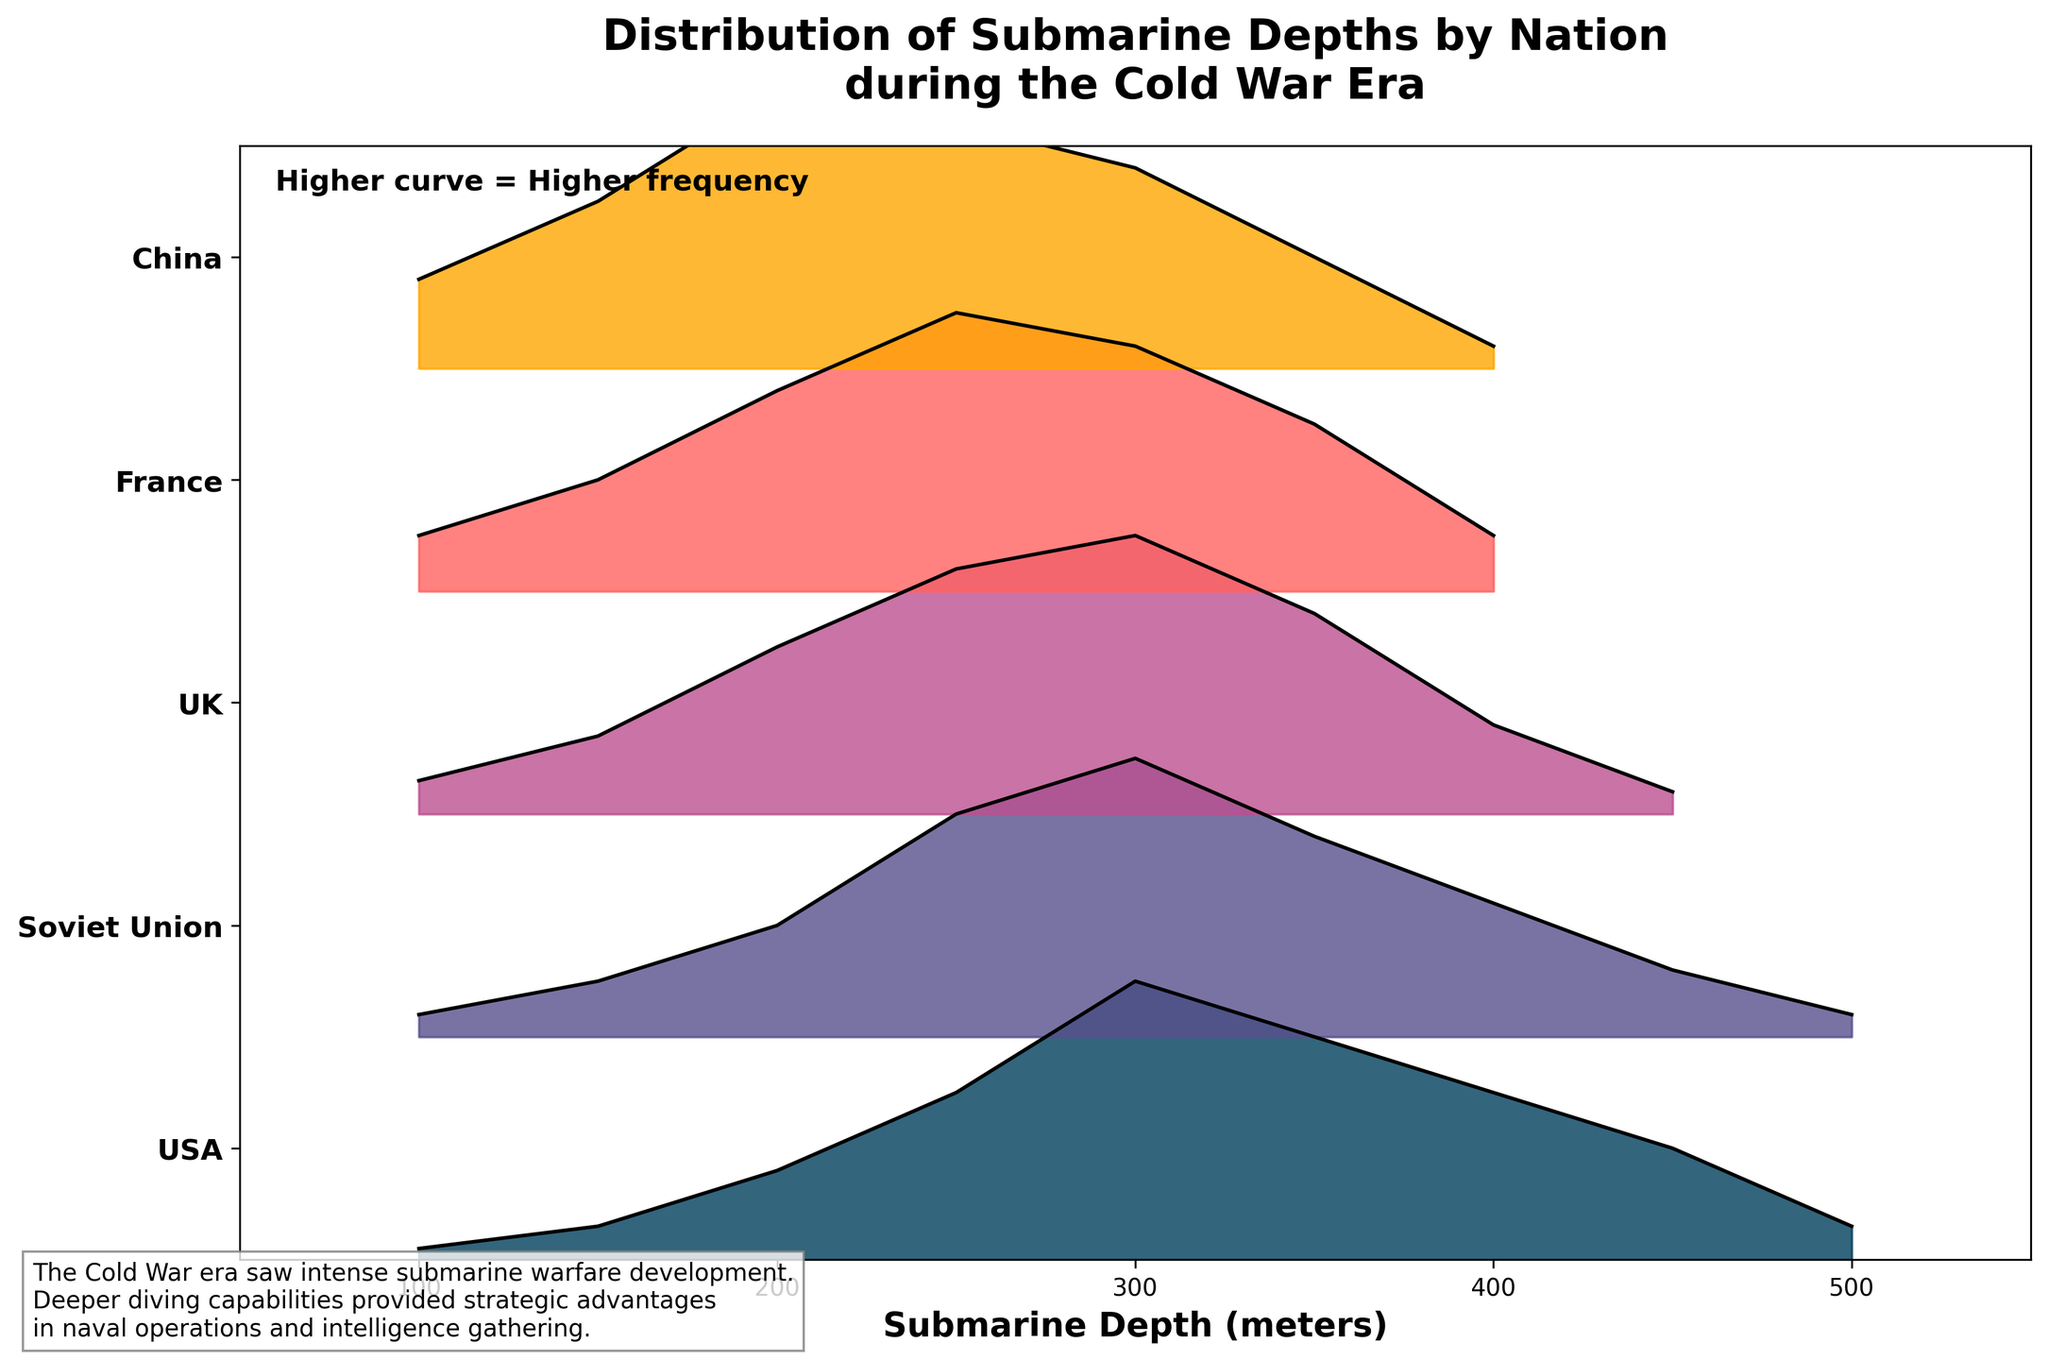Which nation has the highest frequency of submarines operating at a depth of 300 meters? The ridgeline plot indicates that each nation's curve at 300 meters has a height proportional to its frequency. Comparing the heights at 300 meters for all nations, the USA has the highest curve.
Answer: USA What is the range of submarine depths included in the figure? The x-axis of the plot represents submarine depths, starting from 100 meters and ending at 500 meters.
Answer: 100 to 500 meters Which nation shows a higher frequency of submarines at 150 meters compared to 450 meters? By comparing the heights of the curves at 150 meters and 450 meters for each nation, the UK shows a higher frequency at 150 meters compared to 450 meters.
Answer: UK What is the total number of nations represented in the plot? Each nation's frequencies are plotted as individual ridgelines, and there are a total of five ridgelines.
Answer: 5 How does the frequency distribution of submarines for the Soviet Union compare at 200 meters and 300 meters? The plot shows the Soviet Union with a frequency of 0.10 at 200 meters and 0.25 at 300 meters by observing the height of curves. The frequency is higher at 300 meters.
Answer: Higher at 300 meters Which nation has the narrowest range of submarine depths with significant frequencies (greater than 0.05)? Looking at the plot, we see that France has significant frequencies from 100 meters to 350 meters, making it the nation with the narrowest range.
Answer: France Overall, which nation appears to have the most balanced frequency distribution across different submarine depths? Observing all curves, China's frequencies are relatively balanced with no extreme peaks or valleys, indicating a more uniform distribution across depths.
Answer: China Is there any nation whose submarines frequently operate beyond 400 meters depth? By inspecting the plot, no nation has a significant frequency beyond 400 meters, as the curve heights quickly drop off after this depth.
Answer: No Which nation has the steepest decline in frequency after 350 meters? The curves' steepness after 350 meters shows the UK and France both have noticeable declines, but the UK's drop is steeper.
Answer: UK Does any nation show a continuous increase in frequency up to 300 meters? By tracing the curves from 100 to 300 meters, all nations show increases up to 300 meters, though with varying steepness. Multiple nations achieve this.
Answer: Multiple nations 